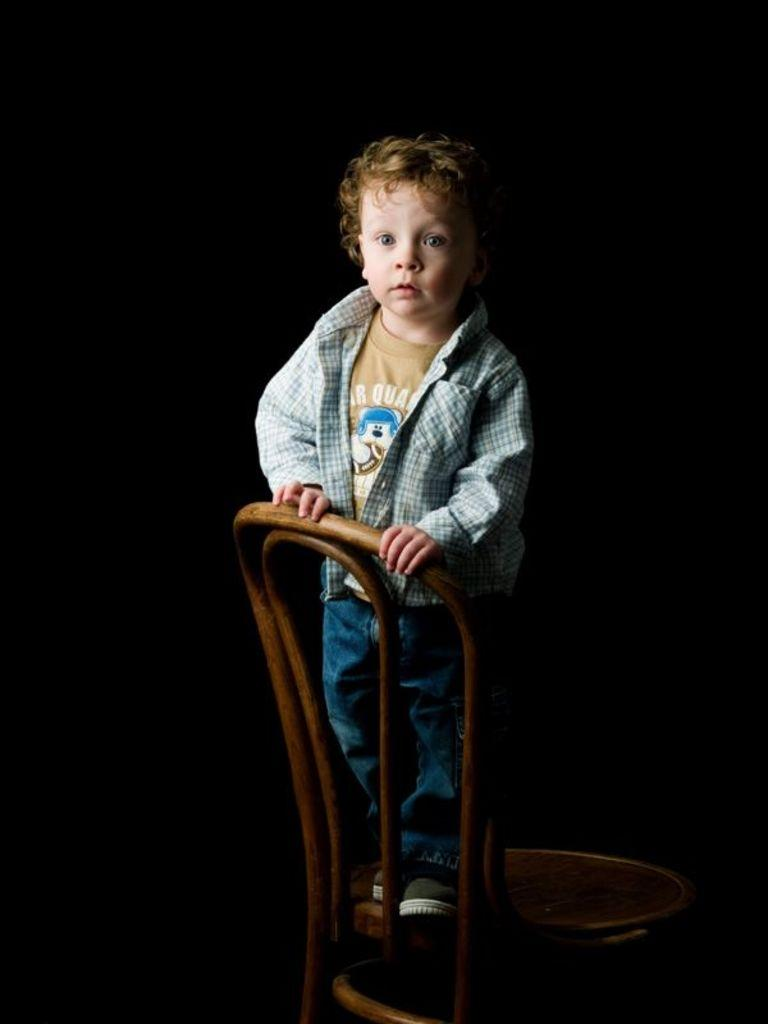What is the main subject of the image? There is a person in the image. What is the person doing in the image? The person is standing on a chair. What else is the person holding in the image? The person is holding a chair. How many trucks can be seen in the image? There are no trucks present in the image. What type of stretch is the person performing while holding the chair? There is no stretch being performed in the image; the person is simply standing on a chair and holding another chair. 